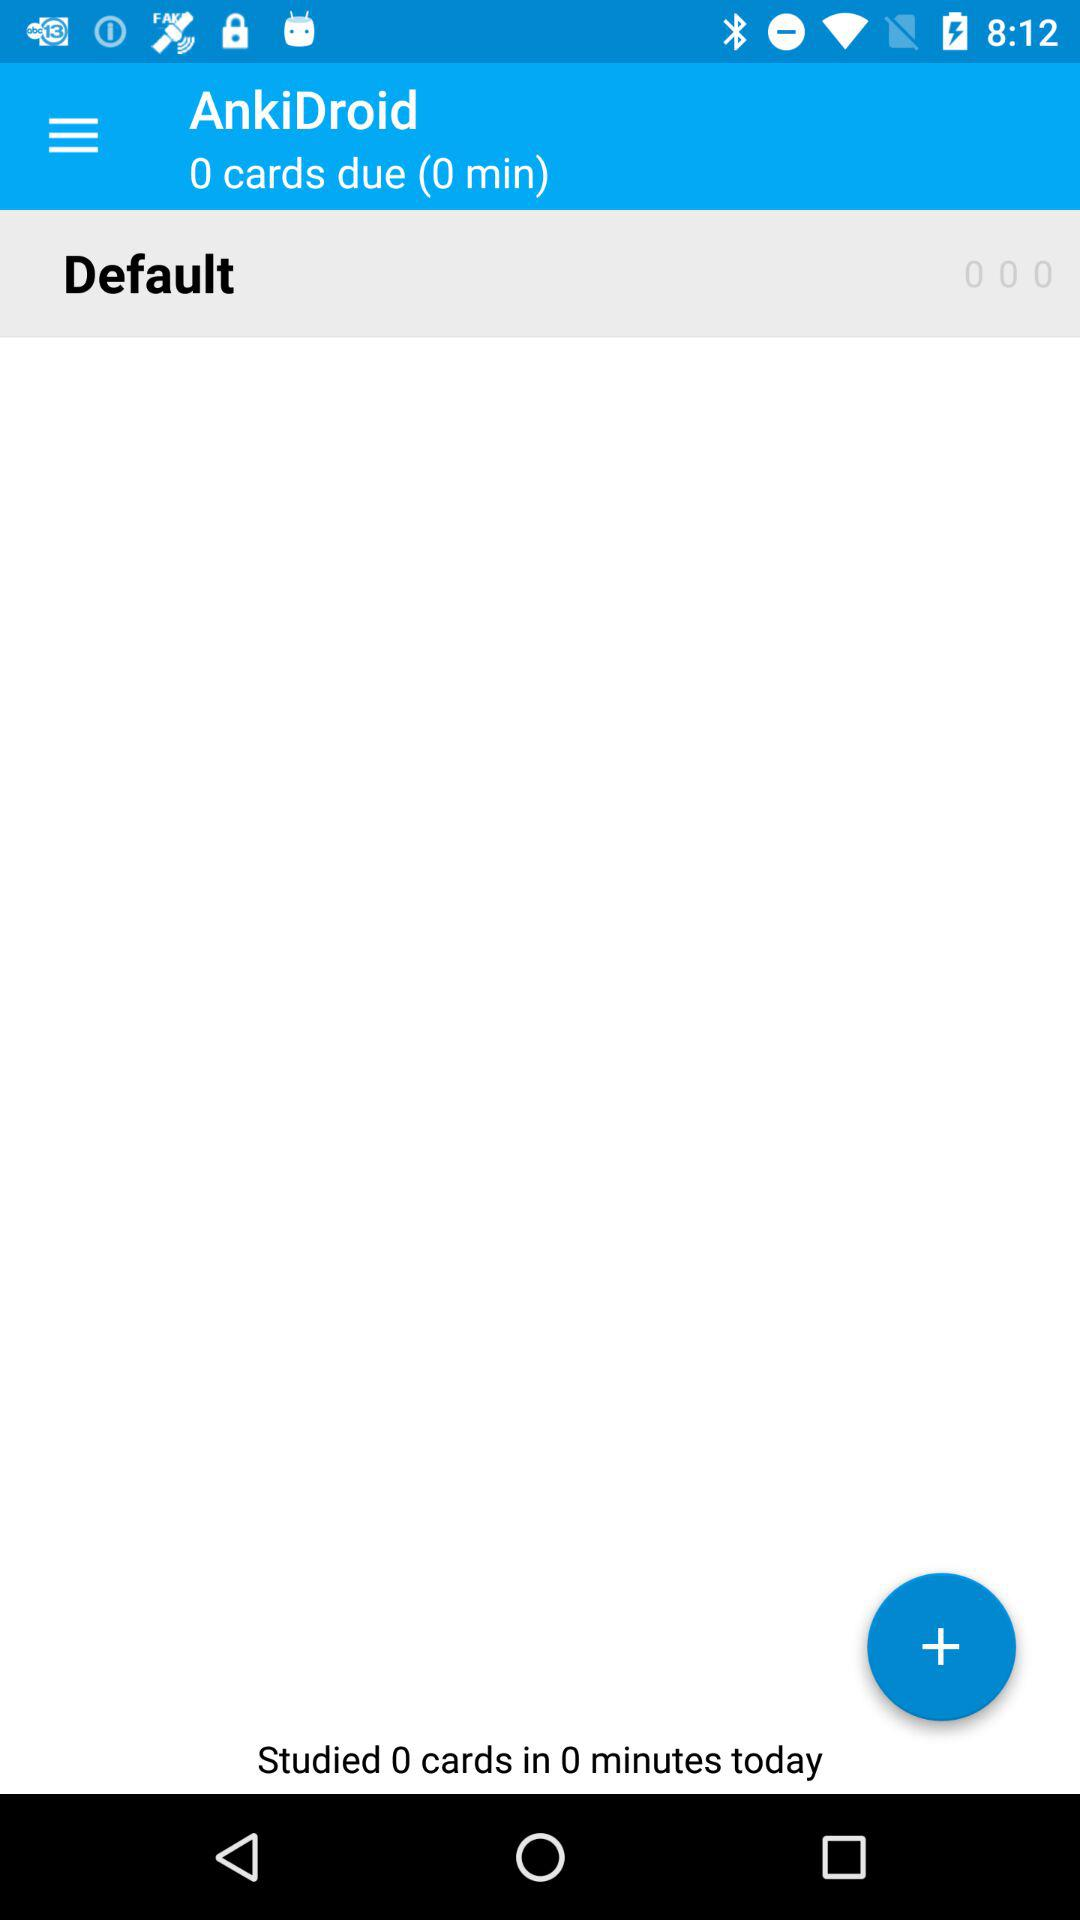How many cards have I studied today?
Answer the question using a single word or phrase. 0 